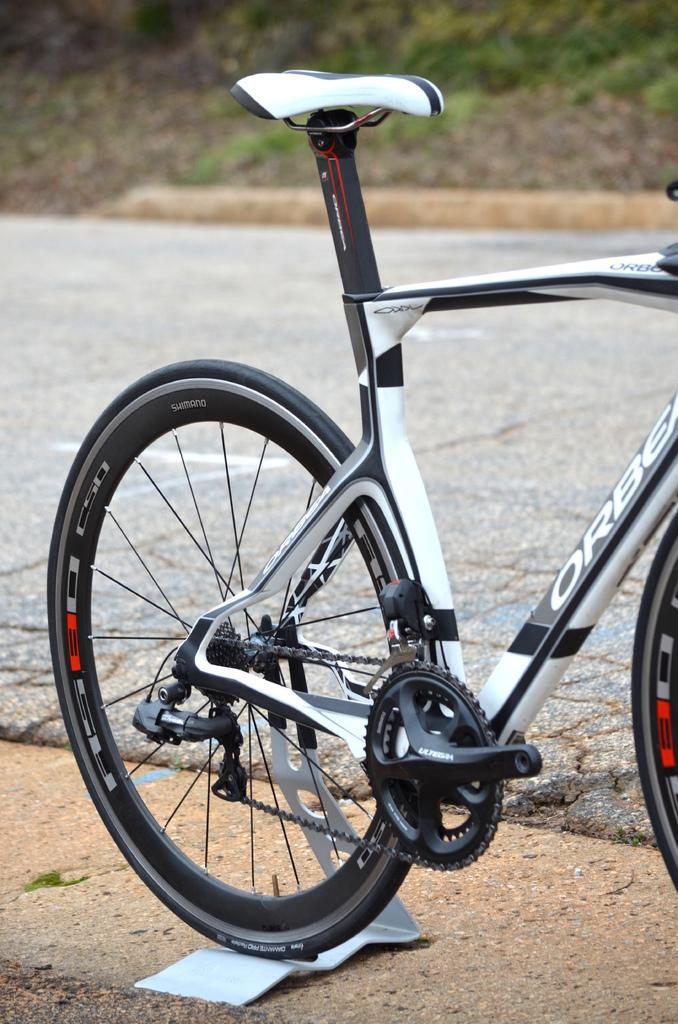Where was the picture taken? The picture was clicked outside. What can be seen in the image besides the background? There is a bicycle in the image in the image. How is the bicycle positioned in the image? The bicycle is parked on the ground. What type of surface is visible in the background? The ground is visible in the background. What color or type of vegetation can be seen in the background? A small portion of green grass is visible in the background. How many stars can be seen in the image? There are no stars visible in the image, as it was taken outside and not in space. 